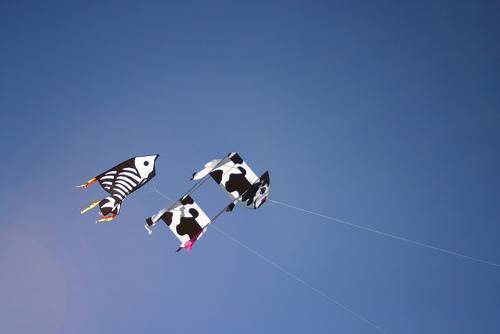How many kites are in the sky?
Give a very brief answer. 2. 